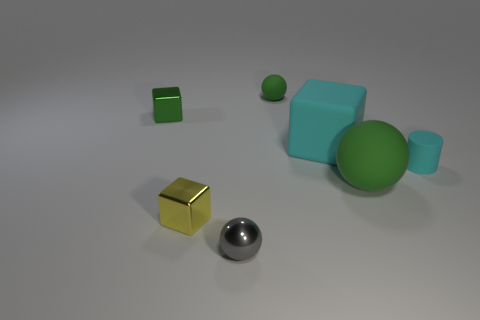There is a block that is the same color as the big rubber sphere; what is it made of?
Offer a terse response. Metal. What is the color of the other ball that is made of the same material as the small green ball?
Your answer should be compact. Green. How big is the metal thing behind the large green rubber thing to the right of the tiny sphere in front of the tiny matte sphere?
Your answer should be compact. Small. Do the small gray ball and the green thing left of the metal sphere have the same material?
Offer a very short reply. Yes. Is the green shiny thing the same shape as the small yellow metal thing?
Make the answer very short. Yes. How many other things are there of the same material as the yellow block?
Offer a very short reply. 2. What number of green objects have the same shape as the small gray metal object?
Your response must be concise. 2. There is a block that is left of the big cyan cube and to the right of the small green shiny cube; what color is it?
Your answer should be compact. Yellow. How many cyan rubber things are there?
Your response must be concise. 2. Do the cyan cube and the cyan matte cylinder have the same size?
Provide a succinct answer. No. 